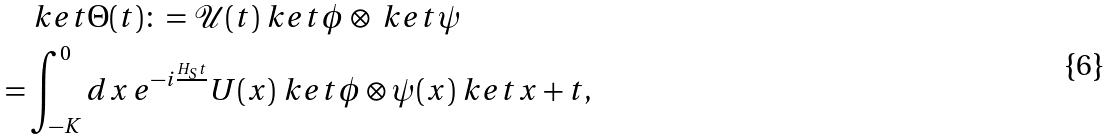Convert formula to latex. <formula><loc_0><loc_0><loc_500><loc_500>& \ k e t { \Theta ( t ) } \colon = \mathcal { U } ( t ) \ k e t { \phi } \otimes \ k e t { \psi } \\ = & \int _ { - K } ^ { 0 } d x \, e ^ { - i \frac { H _ { S } t } { } } U ( x ) \ k e t { \phi } \otimes \psi ( x ) \ k e t { x + t } ,</formula> 